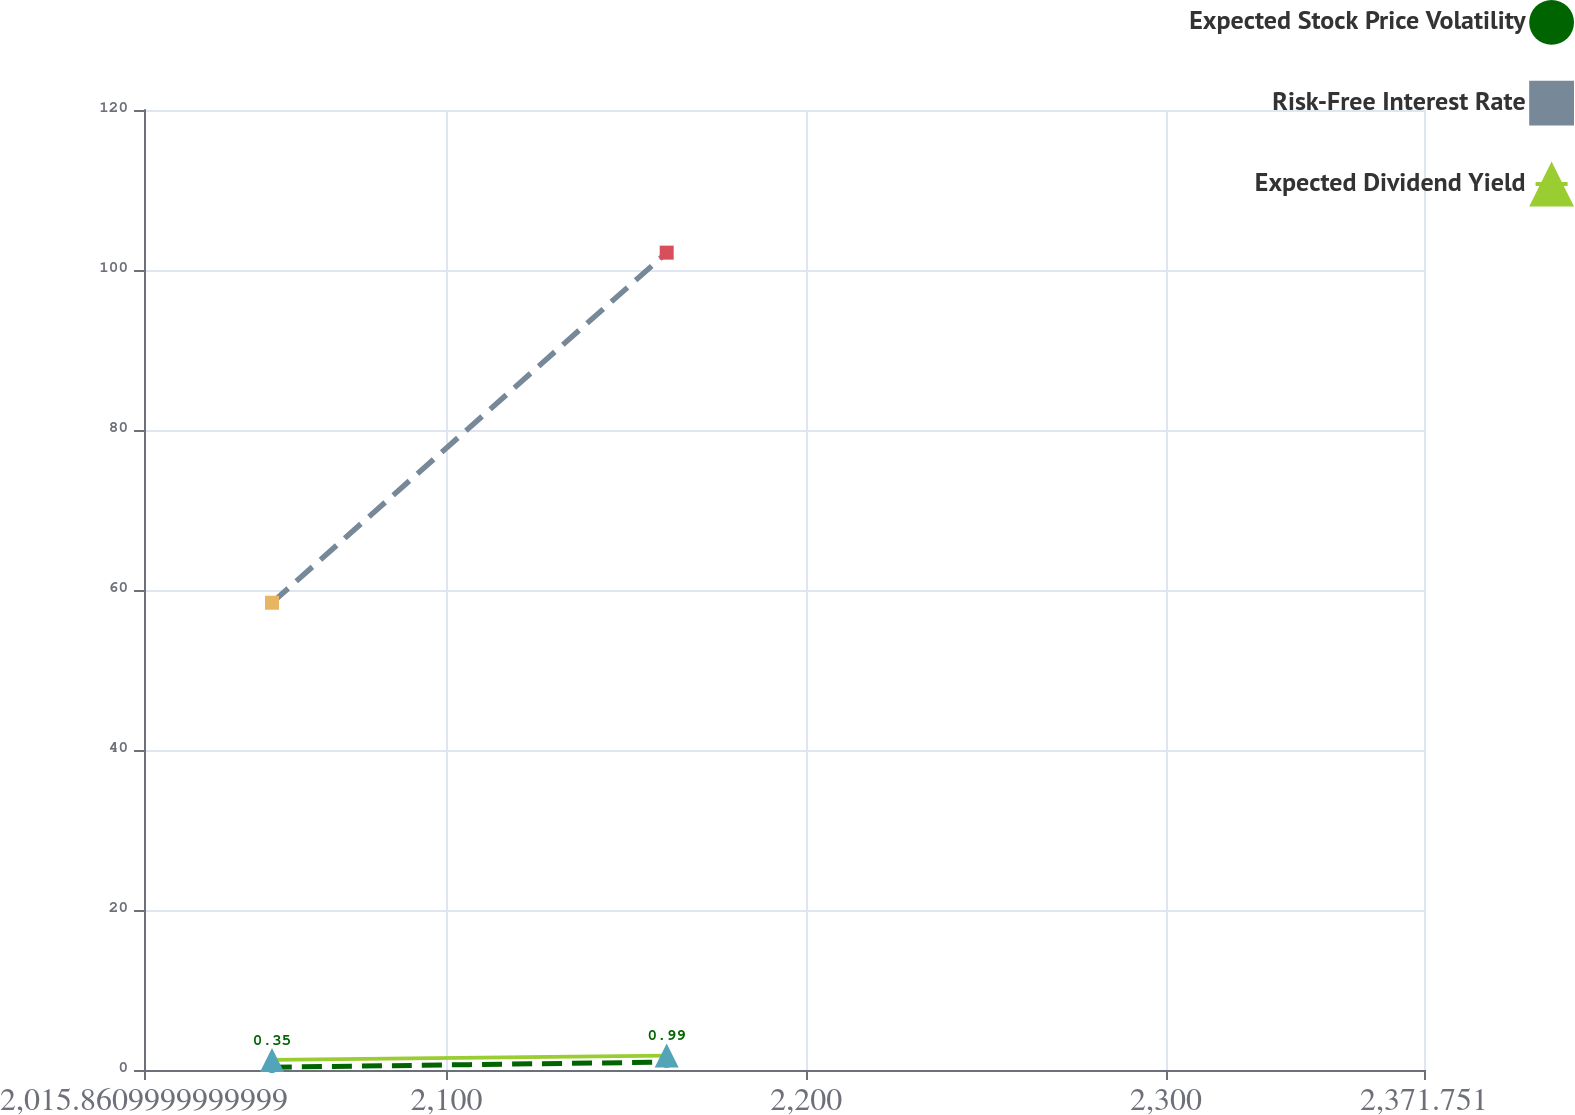Convert chart. <chart><loc_0><loc_0><loc_500><loc_500><line_chart><ecel><fcel>Expected Stock Price Volatility<fcel>Risk-Free Interest Rate<fcel>Expected Dividend Yield<nl><fcel>2051.45<fcel>0.35<fcel>58.41<fcel>1.26<nl><fcel>2161.19<fcel>0.99<fcel>102.17<fcel>1.8<nl><fcel>2407.34<fcel>1.21<fcel>80.41<fcel>0.58<nl></chart> 